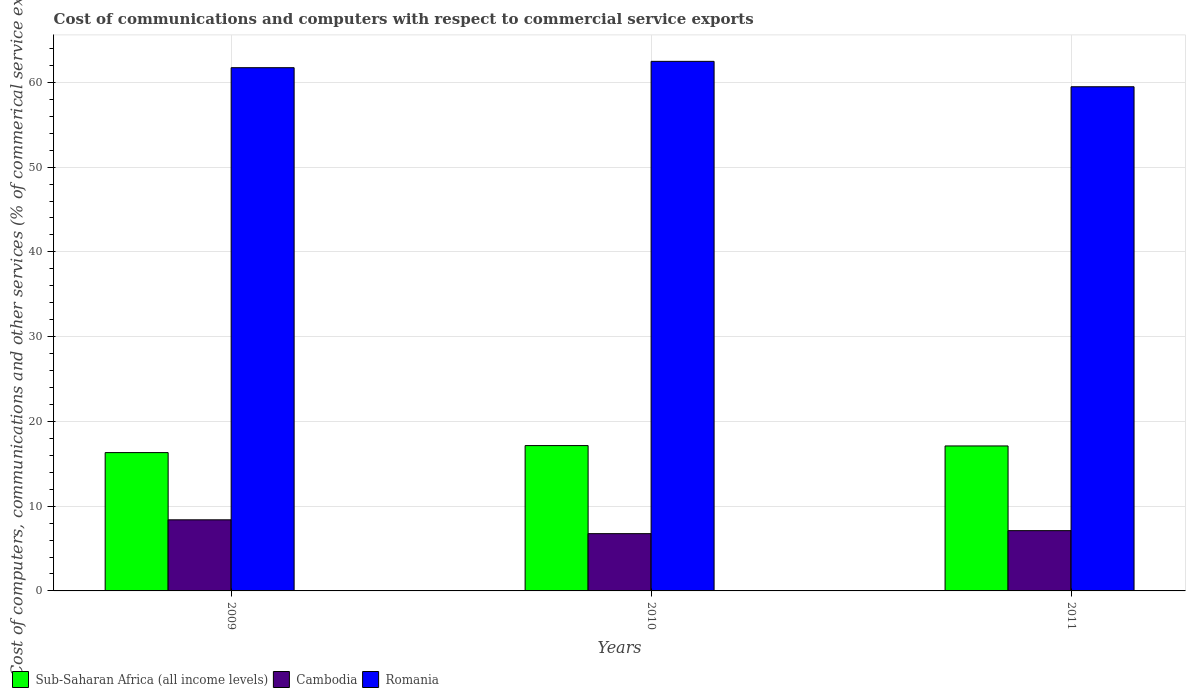How many groups of bars are there?
Your response must be concise. 3. Are the number of bars on each tick of the X-axis equal?
Provide a short and direct response. Yes. What is the label of the 2nd group of bars from the left?
Provide a short and direct response. 2010. What is the cost of communications and computers in Sub-Saharan Africa (all income levels) in 2009?
Ensure brevity in your answer.  16.32. Across all years, what is the maximum cost of communications and computers in Sub-Saharan Africa (all income levels)?
Your response must be concise. 17.15. Across all years, what is the minimum cost of communications and computers in Romania?
Make the answer very short. 59.48. In which year was the cost of communications and computers in Romania minimum?
Your answer should be very brief. 2011. What is the total cost of communications and computers in Romania in the graph?
Make the answer very short. 183.69. What is the difference between the cost of communications and computers in Romania in 2009 and that in 2010?
Provide a short and direct response. -0.75. What is the difference between the cost of communications and computers in Sub-Saharan Africa (all income levels) in 2011 and the cost of communications and computers in Romania in 2009?
Keep it short and to the point. -44.63. What is the average cost of communications and computers in Sub-Saharan Africa (all income levels) per year?
Your answer should be compact. 16.86. In the year 2010, what is the difference between the cost of communications and computers in Cambodia and cost of communications and computers in Romania?
Keep it short and to the point. -55.72. In how many years, is the cost of communications and computers in Cambodia greater than 28 %?
Make the answer very short. 0. What is the ratio of the cost of communications and computers in Romania in 2009 to that in 2010?
Make the answer very short. 0.99. Is the cost of communications and computers in Romania in 2009 less than that in 2010?
Make the answer very short. Yes. Is the difference between the cost of communications and computers in Cambodia in 2009 and 2011 greater than the difference between the cost of communications and computers in Romania in 2009 and 2011?
Your answer should be very brief. No. What is the difference between the highest and the second highest cost of communications and computers in Cambodia?
Your response must be concise. 1.28. What is the difference between the highest and the lowest cost of communications and computers in Sub-Saharan Africa (all income levels)?
Your response must be concise. 0.83. What does the 1st bar from the left in 2011 represents?
Provide a short and direct response. Sub-Saharan Africa (all income levels). What does the 1st bar from the right in 2009 represents?
Offer a very short reply. Romania. Is it the case that in every year, the sum of the cost of communications and computers in Romania and cost of communications and computers in Sub-Saharan Africa (all income levels) is greater than the cost of communications and computers in Cambodia?
Your answer should be very brief. Yes. How many bars are there?
Ensure brevity in your answer.  9. How many years are there in the graph?
Give a very brief answer. 3. What is the difference between two consecutive major ticks on the Y-axis?
Your answer should be compact. 10. Are the values on the major ticks of Y-axis written in scientific E-notation?
Provide a succinct answer. No. Does the graph contain any zero values?
Give a very brief answer. No. What is the title of the graph?
Keep it short and to the point. Cost of communications and computers with respect to commercial service exports. What is the label or title of the X-axis?
Your answer should be compact. Years. What is the label or title of the Y-axis?
Keep it short and to the point. Cost of computers, communications and other services (% of commerical service exports). What is the Cost of computers, communications and other services (% of commerical service exports) in Sub-Saharan Africa (all income levels) in 2009?
Offer a terse response. 16.32. What is the Cost of computers, communications and other services (% of commerical service exports) of Cambodia in 2009?
Offer a very short reply. 8.39. What is the Cost of computers, communications and other services (% of commerical service exports) of Romania in 2009?
Provide a succinct answer. 61.73. What is the Cost of computers, communications and other services (% of commerical service exports) in Sub-Saharan Africa (all income levels) in 2010?
Ensure brevity in your answer.  17.15. What is the Cost of computers, communications and other services (% of commerical service exports) in Cambodia in 2010?
Offer a terse response. 6.76. What is the Cost of computers, communications and other services (% of commerical service exports) of Romania in 2010?
Offer a very short reply. 62.48. What is the Cost of computers, communications and other services (% of commerical service exports) in Sub-Saharan Africa (all income levels) in 2011?
Offer a terse response. 17.1. What is the Cost of computers, communications and other services (% of commerical service exports) of Cambodia in 2011?
Keep it short and to the point. 7.11. What is the Cost of computers, communications and other services (% of commerical service exports) of Romania in 2011?
Offer a very short reply. 59.48. Across all years, what is the maximum Cost of computers, communications and other services (% of commerical service exports) in Sub-Saharan Africa (all income levels)?
Keep it short and to the point. 17.15. Across all years, what is the maximum Cost of computers, communications and other services (% of commerical service exports) of Cambodia?
Make the answer very short. 8.39. Across all years, what is the maximum Cost of computers, communications and other services (% of commerical service exports) of Romania?
Your answer should be very brief. 62.48. Across all years, what is the minimum Cost of computers, communications and other services (% of commerical service exports) of Sub-Saharan Africa (all income levels)?
Make the answer very short. 16.32. Across all years, what is the minimum Cost of computers, communications and other services (% of commerical service exports) of Cambodia?
Your answer should be very brief. 6.76. Across all years, what is the minimum Cost of computers, communications and other services (% of commerical service exports) of Romania?
Your answer should be very brief. 59.48. What is the total Cost of computers, communications and other services (% of commerical service exports) in Sub-Saharan Africa (all income levels) in the graph?
Provide a short and direct response. 50.57. What is the total Cost of computers, communications and other services (% of commerical service exports) in Cambodia in the graph?
Provide a short and direct response. 22.26. What is the total Cost of computers, communications and other services (% of commerical service exports) in Romania in the graph?
Keep it short and to the point. 183.69. What is the difference between the Cost of computers, communications and other services (% of commerical service exports) in Sub-Saharan Africa (all income levels) in 2009 and that in 2010?
Offer a very short reply. -0.83. What is the difference between the Cost of computers, communications and other services (% of commerical service exports) of Cambodia in 2009 and that in 2010?
Keep it short and to the point. 1.63. What is the difference between the Cost of computers, communications and other services (% of commerical service exports) in Romania in 2009 and that in 2010?
Your answer should be compact. -0.75. What is the difference between the Cost of computers, communications and other services (% of commerical service exports) of Sub-Saharan Africa (all income levels) in 2009 and that in 2011?
Provide a succinct answer. -0.79. What is the difference between the Cost of computers, communications and other services (% of commerical service exports) of Cambodia in 2009 and that in 2011?
Provide a succinct answer. 1.28. What is the difference between the Cost of computers, communications and other services (% of commerical service exports) of Romania in 2009 and that in 2011?
Make the answer very short. 2.25. What is the difference between the Cost of computers, communications and other services (% of commerical service exports) in Sub-Saharan Africa (all income levels) in 2010 and that in 2011?
Offer a terse response. 0.04. What is the difference between the Cost of computers, communications and other services (% of commerical service exports) of Cambodia in 2010 and that in 2011?
Offer a very short reply. -0.35. What is the difference between the Cost of computers, communications and other services (% of commerical service exports) of Romania in 2010 and that in 2011?
Give a very brief answer. 3. What is the difference between the Cost of computers, communications and other services (% of commerical service exports) in Sub-Saharan Africa (all income levels) in 2009 and the Cost of computers, communications and other services (% of commerical service exports) in Cambodia in 2010?
Offer a very short reply. 9.56. What is the difference between the Cost of computers, communications and other services (% of commerical service exports) of Sub-Saharan Africa (all income levels) in 2009 and the Cost of computers, communications and other services (% of commerical service exports) of Romania in 2010?
Your answer should be compact. -46.16. What is the difference between the Cost of computers, communications and other services (% of commerical service exports) of Cambodia in 2009 and the Cost of computers, communications and other services (% of commerical service exports) of Romania in 2010?
Provide a succinct answer. -54.09. What is the difference between the Cost of computers, communications and other services (% of commerical service exports) of Sub-Saharan Africa (all income levels) in 2009 and the Cost of computers, communications and other services (% of commerical service exports) of Cambodia in 2011?
Provide a short and direct response. 9.21. What is the difference between the Cost of computers, communications and other services (% of commerical service exports) of Sub-Saharan Africa (all income levels) in 2009 and the Cost of computers, communications and other services (% of commerical service exports) of Romania in 2011?
Make the answer very short. -43.16. What is the difference between the Cost of computers, communications and other services (% of commerical service exports) in Cambodia in 2009 and the Cost of computers, communications and other services (% of commerical service exports) in Romania in 2011?
Ensure brevity in your answer.  -51.09. What is the difference between the Cost of computers, communications and other services (% of commerical service exports) of Sub-Saharan Africa (all income levels) in 2010 and the Cost of computers, communications and other services (% of commerical service exports) of Cambodia in 2011?
Your answer should be very brief. 10.04. What is the difference between the Cost of computers, communications and other services (% of commerical service exports) in Sub-Saharan Africa (all income levels) in 2010 and the Cost of computers, communications and other services (% of commerical service exports) in Romania in 2011?
Offer a very short reply. -42.34. What is the difference between the Cost of computers, communications and other services (% of commerical service exports) of Cambodia in 2010 and the Cost of computers, communications and other services (% of commerical service exports) of Romania in 2011?
Offer a very short reply. -52.73. What is the average Cost of computers, communications and other services (% of commerical service exports) of Sub-Saharan Africa (all income levels) per year?
Provide a short and direct response. 16.86. What is the average Cost of computers, communications and other services (% of commerical service exports) of Cambodia per year?
Your answer should be compact. 7.42. What is the average Cost of computers, communications and other services (% of commerical service exports) of Romania per year?
Give a very brief answer. 61.23. In the year 2009, what is the difference between the Cost of computers, communications and other services (% of commerical service exports) of Sub-Saharan Africa (all income levels) and Cost of computers, communications and other services (% of commerical service exports) of Cambodia?
Give a very brief answer. 7.93. In the year 2009, what is the difference between the Cost of computers, communications and other services (% of commerical service exports) of Sub-Saharan Africa (all income levels) and Cost of computers, communications and other services (% of commerical service exports) of Romania?
Your answer should be compact. -45.41. In the year 2009, what is the difference between the Cost of computers, communications and other services (% of commerical service exports) of Cambodia and Cost of computers, communications and other services (% of commerical service exports) of Romania?
Offer a very short reply. -53.34. In the year 2010, what is the difference between the Cost of computers, communications and other services (% of commerical service exports) in Sub-Saharan Africa (all income levels) and Cost of computers, communications and other services (% of commerical service exports) in Cambodia?
Ensure brevity in your answer.  10.39. In the year 2010, what is the difference between the Cost of computers, communications and other services (% of commerical service exports) of Sub-Saharan Africa (all income levels) and Cost of computers, communications and other services (% of commerical service exports) of Romania?
Offer a very short reply. -45.33. In the year 2010, what is the difference between the Cost of computers, communications and other services (% of commerical service exports) in Cambodia and Cost of computers, communications and other services (% of commerical service exports) in Romania?
Your answer should be very brief. -55.72. In the year 2011, what is the difference between the Cost of computers, communications and other services (% of commerical service exports) of Sub-Saharan Africa (all income levels) and Cost of computers, communications and other services (% of commerical service exports) of Cambodia?
Make the answer very short. 9.99. In the year 2011, what is the difference between the Cost of computers, communications and other services (% of commerical service exports) in Sub-Saharan Africa (all income levels) and Cost of computers, communications and other services (% of commerical service exports) in Romania?
Your response must be concise. -42.38. In the year 2011, what is the difference between the Cost of computers, communications and other services (% of commerical service exports) of Cambodia and Cost of computers, communications and other services (% of commerical service exports) of Romania?
Ensure brevity in your answer.  -52.37. What is the ratio of the Cost of computers, communications and other services (% of commerical service exports) in Sub-Saharan Africa (all income levels) in 2009 to that in 2010?
Give a very brief answer. 0.95. What is the ratio of the Cost of computers, communications and other services (% of commerical service exports) of Cambodia in 2009 to that in 2010?
Ensure brevity in your answer.  1.24. What is the ratio of the Cost of computers, communications and other services (% of commerical service exports) of Romania in 2009 to that in 2010?
Ensure brevity in your answer.  0.99. What is the ratio of the Cost of computers, communications and other services (% of commerical service exports) in Sub-Saharan Africa (all income levels) in 2009 to that in 2011?
Your answer should be very brief. 0.95. What is the ratio of the Cost of computers, communications and other services (% of commerical service exports) in Cambodia in 2009 to that in 2011?
Keep it short and to the point. 1.18. What is the ratio of the Cost of computers, communications and other services (% of commerical service exports) in Romania in 2009 to that in 2011?
Provide a short and direct response. 1.04. What is the ratio of the Cost of computers, communications and other services (% of commerical service exports) of Sub-Saharan Africa (all income levels) in 2010 to that in 2011?
Give a very brief answer. 1. What is the ratio of the Cost of computers, communications and other services (% of commerical service exports) of Cambodia in 2010 to that in 2011?
Offer a very short reply. 0.95. What is the ratio of the Cost of computers, communications and other services (% of commerical service exports) in Romania in 2010 to that in 2011?
Offer a very short reply. 1.05. What is the difference between the highest and the second highest Cost of computers, communications and other services (% of commerical service exports) of Sub-Saharan Africa (all income levels)?
Provide a short and direct response. 0.04. What is the difference between the highest and the second highest Cost of computers, communications and other services (% of commerical service exports) in Cambodia?
Provide a succinct answer. 1.28. What is the difference between the highest and the second highest Cost of computers, communications and other services (% of commerical service exports) of Romania?
Give a very brief answer. 0.75. What is the difference between the highest and the lowest Cost of computers, communications and other services (% of commerical service exports) in Sub-Saharan Africa (all income levels)?
Offer a very short reply. 0.83. What is the difference between the highest and the lowest Cost of computers, communications and other services (% of commerical service exports) of Cambodia?
Make the answer very short. 1.63. What is the difference between the highest and the lowest Cost of computers, communications and other services (% of commerical service exports) in Romania?
Ensure brevity in your answer.  3. 